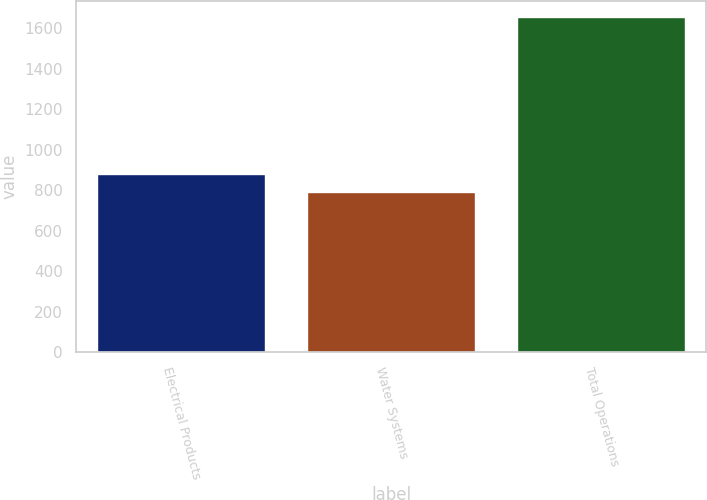Convert chart to OTSL. <chart><loc_0><loc_0><loc_500><loc_500><bar_chart><fcel>Electrical Products<fcel>Water Systems<fcel>Total Operations<nl><fcel>878.47<fcel>792.4<fcel>1653.1<nl></chart> 